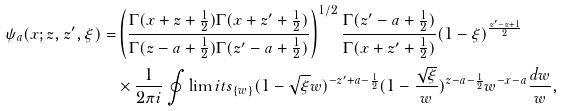<formula> <loc_0><loc_0><loc_500><loc_500>\psi _ { a } ( x ; z , z ^ { \prime } , \xi ) = & \left ( \frac { \Gamma ( x + z + \frac { 1 } { 2 } ) \Gamma ( x + z ^ { \prime } + \frac { 1 } { 2 } ) } { \Gamma ( z - a + \frac { 1 } { 2 } ) \Gamma ( z ^ { \prime } - a + \frac { 1 } { 2 } ) } \right ) ^ { 1 / 2 } \frac { \Gamma ( z ^ { \prime } - a + \frac { 1 } { 2 } ) } { \Gamma ( x + z ^ { \prime } + \frac { 1 } { 2 } ) } ( 1 - \xi ) ^ { \frac { z ^ { \prime } - z + 1 } { 2 } } \\ & \times \frac { 1 } { 2 \pi i } \oint \lim i t s _ { \{ w \} } ( 1 - \sqrt { \xi } w ) ^ { - z ^ { \prime } + a - \frac { 1 } { 2 } } ( 1 - \frac { \sqrt { \xi } } { w } ) ^ { z - a - \frac { 1 } { 2 } } w ^ { - x - a } \frac { d w } { w } ,</formula> 